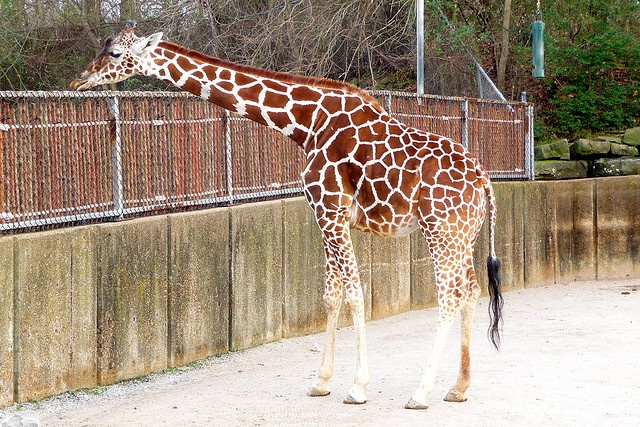Describe the objects in this image and their specific colors. I can see a giraffe in gray, white, maroon, and brown tones in this image. 